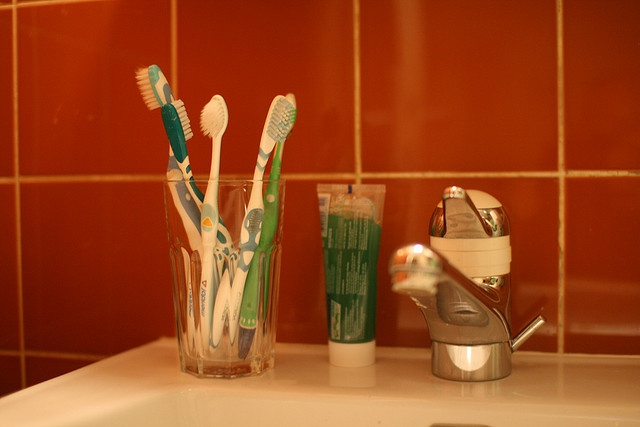Describe the objects in this image and their specific colors. I can see sink in maroon, tan, and brown tones, cup in maroon, brown, tan, and olive tones, toothbrush in maroon, tan, and olive tones, toothbrush in maroon and tan tones, and toothbrush in maroon, olive, and brown tones in this image. 